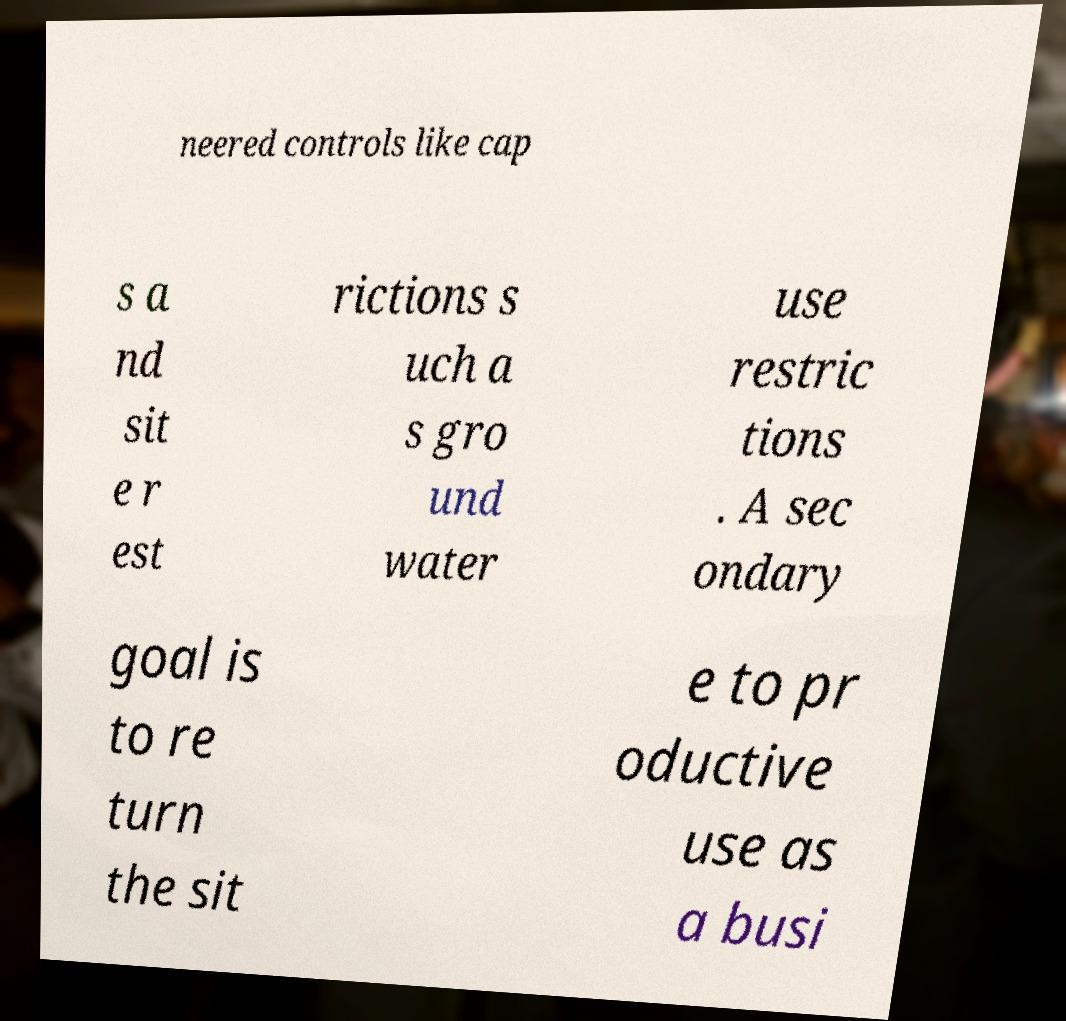What messages or text are displayed in this image? I need them in a readable, typed format. neered controls like cap s a nd sit e r est rictions s uch a s gro und water use restric tions . A sec ondary goal is to re turn the sit e to pr oductive use as a busi 